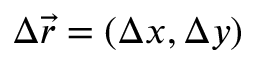<formula> <loc_0><loc_0><loc_500><loc_500>\Delta \vec { r } = ( \Delta x , \Delta y )</formula> 